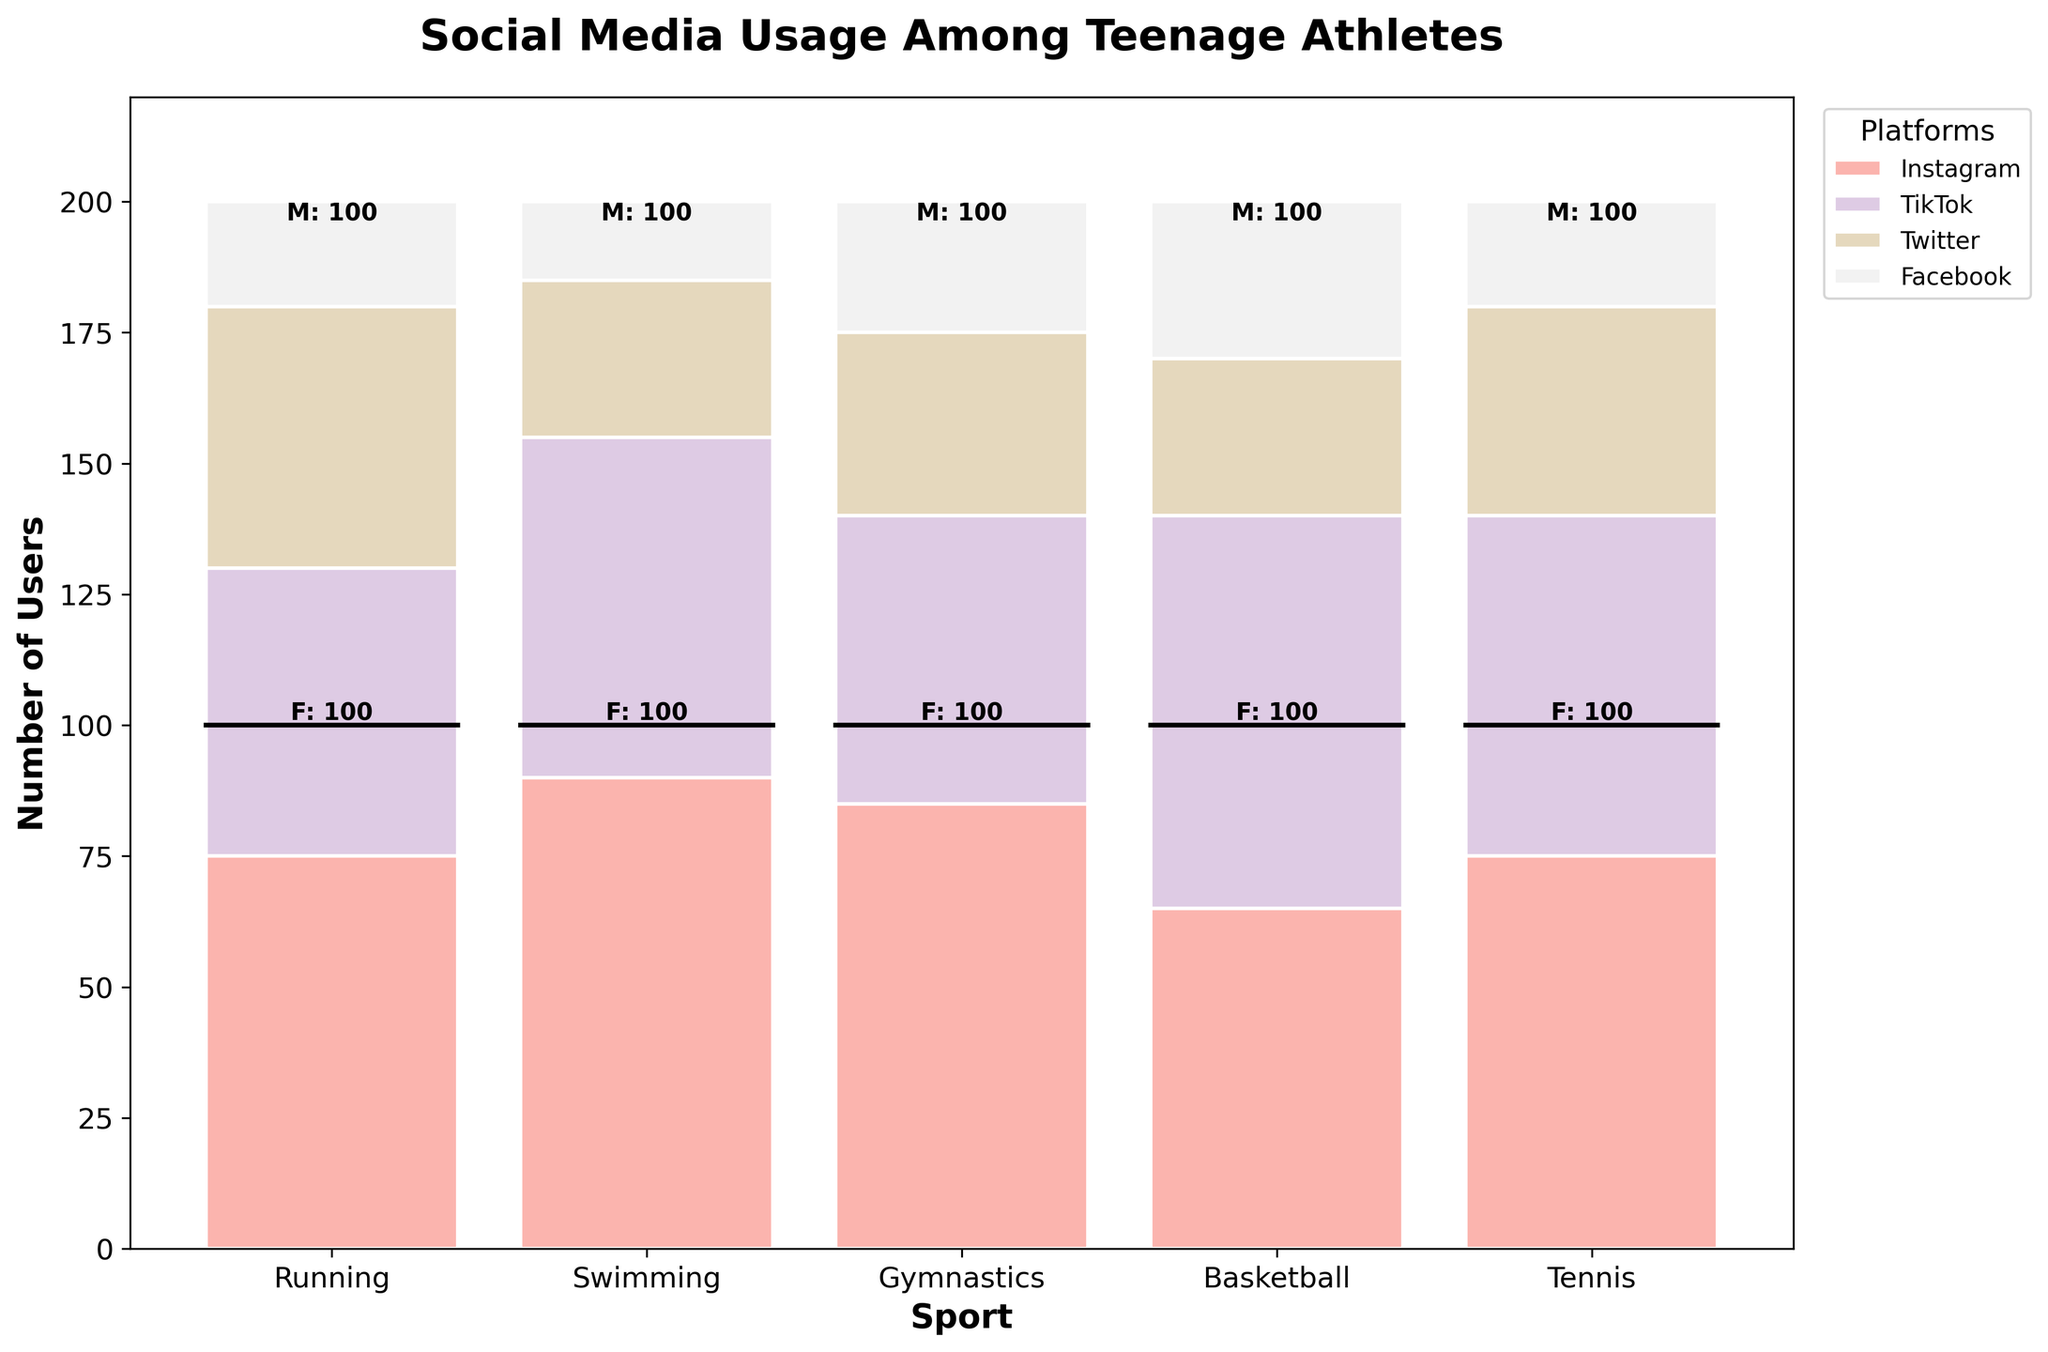What's the title of the figure? The title of the figure is stated at the top, summarizing the content or purpose of the figure.
Answer: Social Media Usage Among Teenage Athletes Which sport has the highest number of female users on Instagram? To find this, look at the Instagram bar segment across sports and check the part of the segment where female users are marked. Gymnastics has the highest segment for female Instagram users.
Answer: Gymnastics How many overall users in TikTok for running compared to swimming? Sum the TikTok user counts for running and swimming from the plot. Running has a total of 55 (30 female + 25 male), and Swimming has 75 (40 female + 35 male).
Answer: Running: 55, Swimming: 75 Which gender uses Twitter more in basketball? Compare the Twitter user segments for male and female in the basketball category by looking at the heights of bars representing Twitter users. Both male and female have the same segment height for Twitter users in basketball.
Answer: Both genders use Twitter equally in basketball What's the total number of Facebook users across all sports? Sum the Facebook user counts for each sport by looking at the heights of the Facebook segments across all sports in the plot. The total should be calculated: 10 + 15 + 15 + 15 + 5 + 10 + 10 + 10 + 10 + 10 = 100.
Answer: 100 Which sport has the lowest total number of users? To find this, look at the bottom segment of each bar representing total users for each sport and identify the shortest bar. Gymnastics has the smallest total user base.
Answer: Gymnastics What's the difference in Instagram users between male tennis players and male basketball players? Find the Instagram user segment for male tennis and male basketball players and calculate their difference: Tennis (35) - Basketball (40) = -5.
Answer: -5 How do the Instagram users compare across sports? Examine the height of the Instagram segments for each sport. Gymnastics and Running lead with the highest number of Instagram users, while Swimming has the fewest Instagram users.
Answer: Gymnastics and Running have the most, Swimming the least What's the average number of TikTok users for males across all sports? Sum the TikTok users for males in each sport and divide by the number of sports: (25+35+30+25+30)/5 = 29.
Answer: 29 